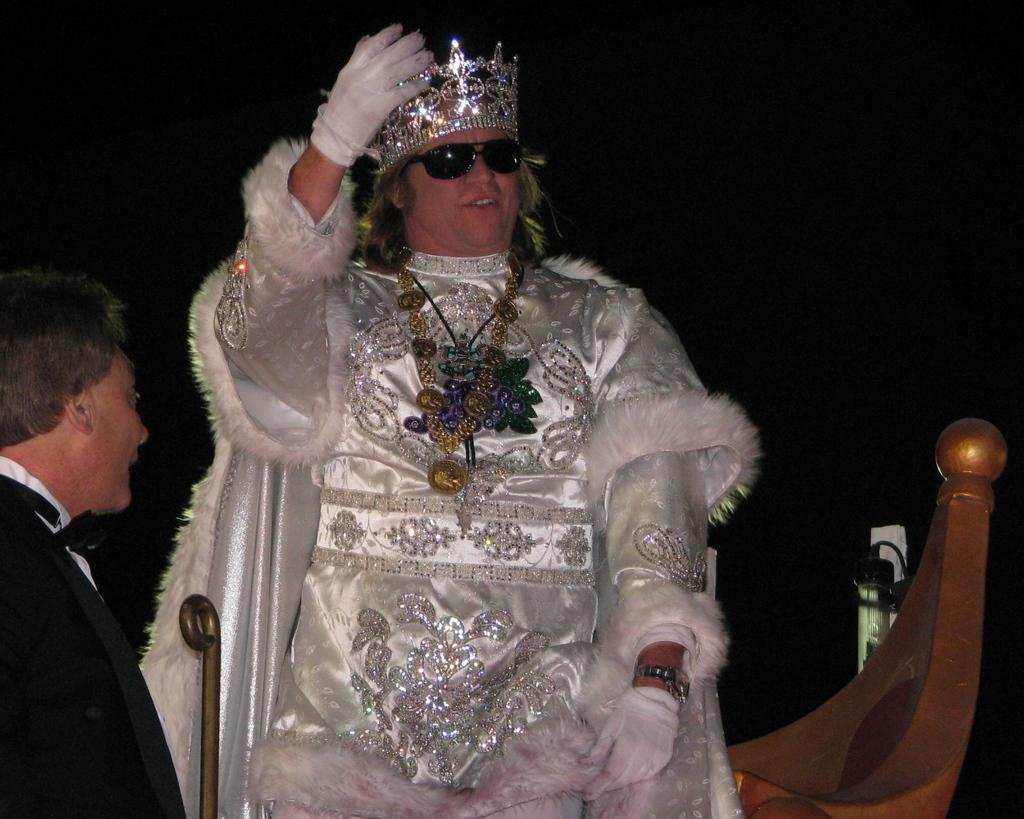How many people are in the image? There is a group of people in the image. Can you describe the man in the middle of the image? The man in the middle of the image is wearing costumes, spectacles, and a crown. What is the background of the image like? The background of the image is dark. What type of holiday is the group of people celebrating in the image? There is no indication of a holiday being celebrated in the image. What is the color of the sky in the image? The provided facts do not mention the sky, so we cannot determine its color. 